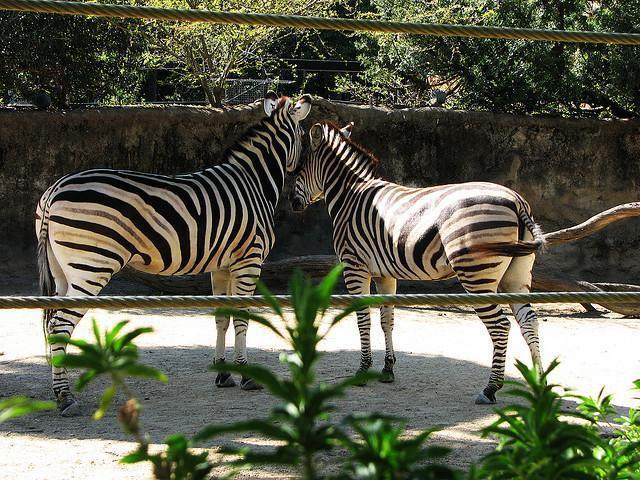How many zebras can be seen?
Give a very brief answer. 2. 